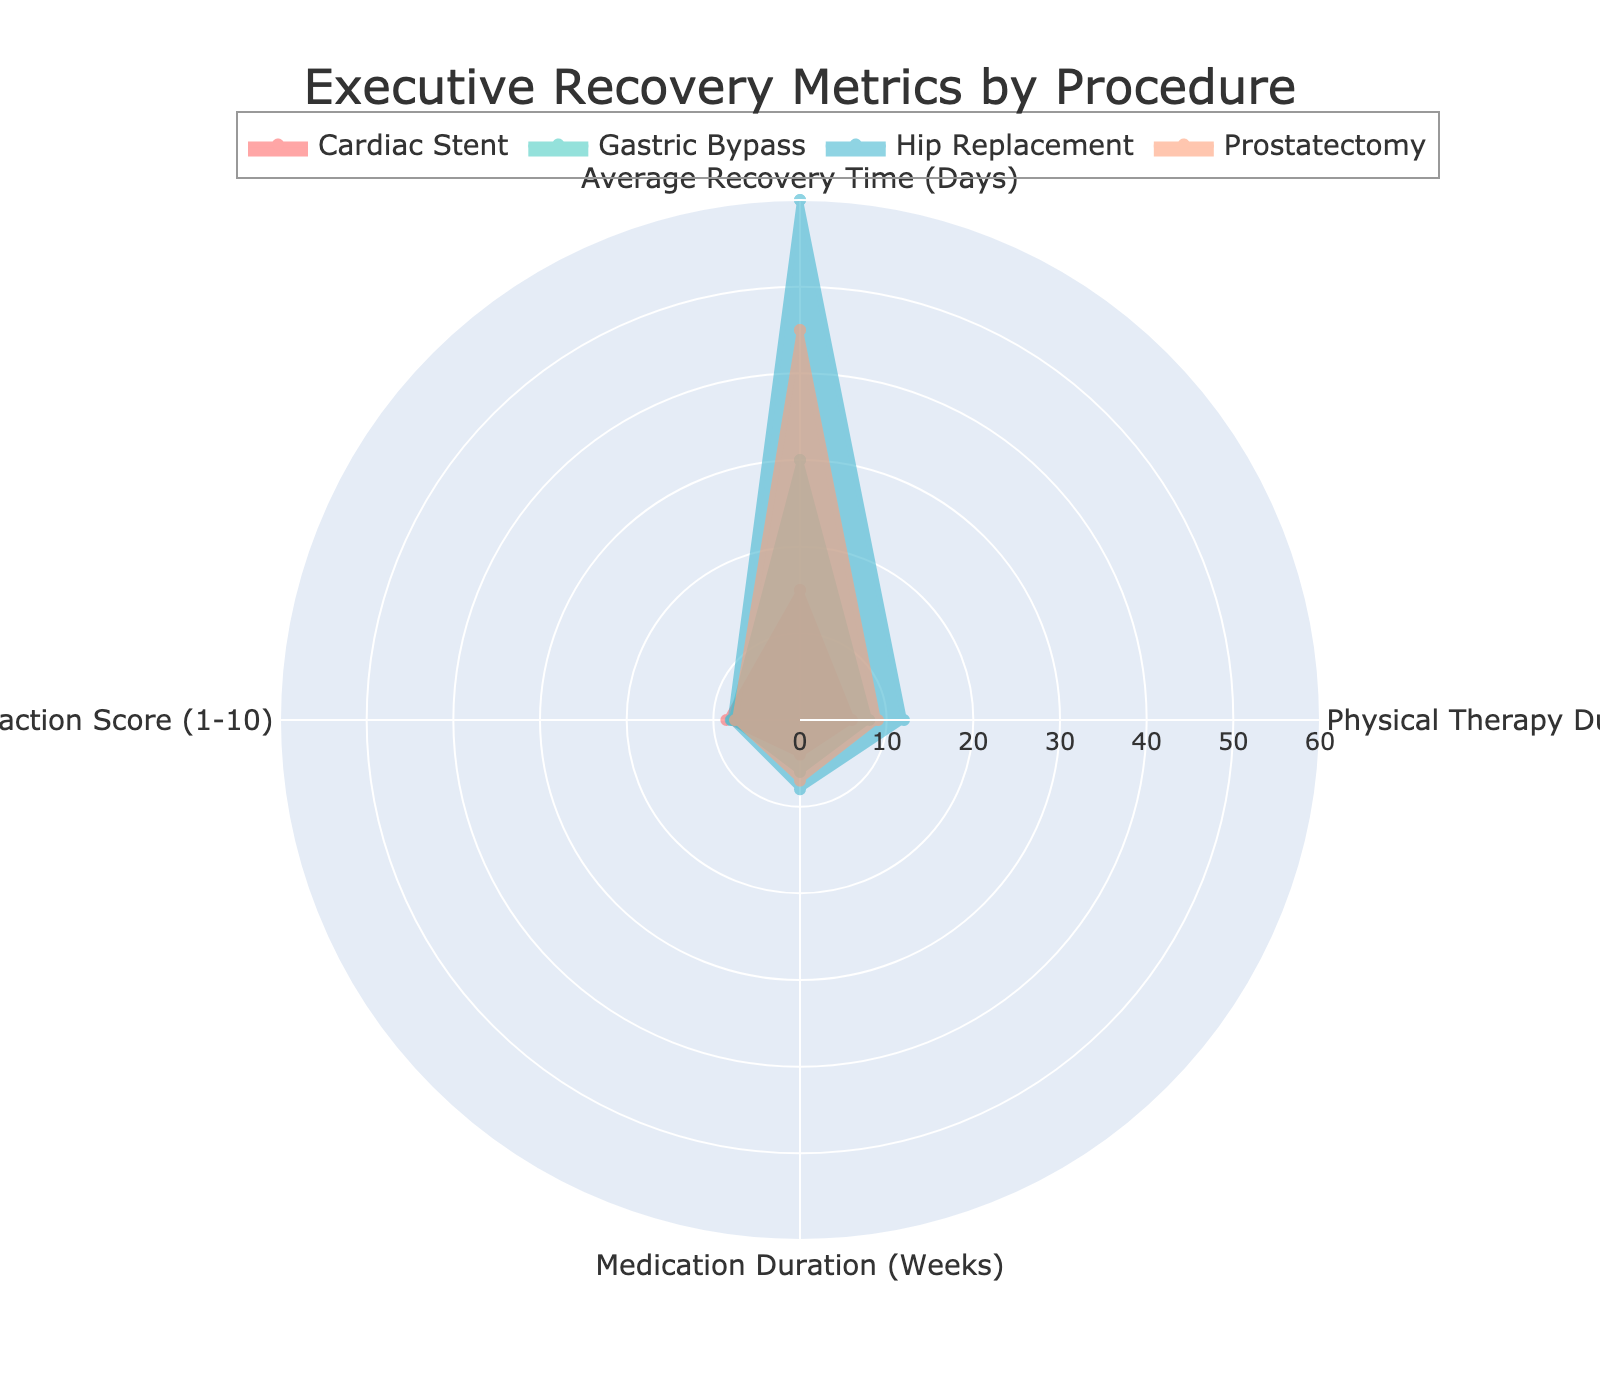How many procedures are compared in the radar chart? The radar chart includes four different interventional procedures being compared. These are listed as 'Cardiac Stent', 'Gastric Bypass', 'Hip Replacement', and 'Prostatectomy'.
Answer: 4 Which procedure has the highest average recovery time? By looking at the 'Average Recovery Time (Days)' category, the polygon with the highest radius corresponds to 'Hip Replacement', indicating it has the longest average recovery time.
Answer: Hip Replacement What is the overall satisfaction score for 'Prostatectomy'? The 'Prostatectomy' procedure's score can be found in the 'Overall Satisfaction Score (1-10)' category. It scores around 7.5.
Answer: 7.5 Which two procedures have the closest overall satisfaction scores? Comparing the 'Overall Satisfaction Score (1-10)' categories, 'Gastric Bypass' with 7.9 and 'Prostatectomy' with 7.5 have the closest scores. The difference is only 0.4.
Answer: Gastric Bypass and Prostatectomy Which procedure requires the longest duration of physical therapy? By looking at the 'Physical Therapy Duration (Weeks)' category, 'Hip Replacement' requires the longest duration, marked by the highest radial value in that category.
Answer: Hip Replacement Compare the physical therapy duration and medication duration for 'Cardiac Stent'. The radar chart shows that 'Cardiac Stent' has a physical therapy duration of 6 weeks and a medication duration of 4 weeks. The physical therapy duration is greater by 2 weeks.
Answer: Physical therapy: 6 weeks, Medication: 4 weeks What is the difference in average recovery time between 'Gastric Bypass' and 'Prostatectomy'? The average recovery time for 'Gastric Bypass' is 30 days, and for 'Prostatectomy' it is 45 days. The difference is calculated as 45 - 30 = 15 days.
Answer: 15 days Which procedure has the lowest medication duration and what is its overall satisfaction score? 'Cardiac Stent' has the lowest medication duration of 4 weeks. Its overall satisfaction score in the radar chart is marked as 8.5.
Answer: Cardiac Stent, 8.5 Which procedure has the highest overall satisfaction score? By observing the 'Overall Satisfaction Score (1-10)' category, 'Cardiac Stent' has the highest satisfaction score of 8.5.
Answer: Cardiac Stent Rank the procedures based on their average recovery time from shortest to longest. The procedures can be ranked based on their 'Average Recovery Time (Days)' as follows: Cardiac Stent (15), Gastric Bypass (30), Prostatectomy (45), Hip Replacement (60).
Answer: Cardiac Stent < Gastric Bypass < Prostatectomy < Hip Replacement 